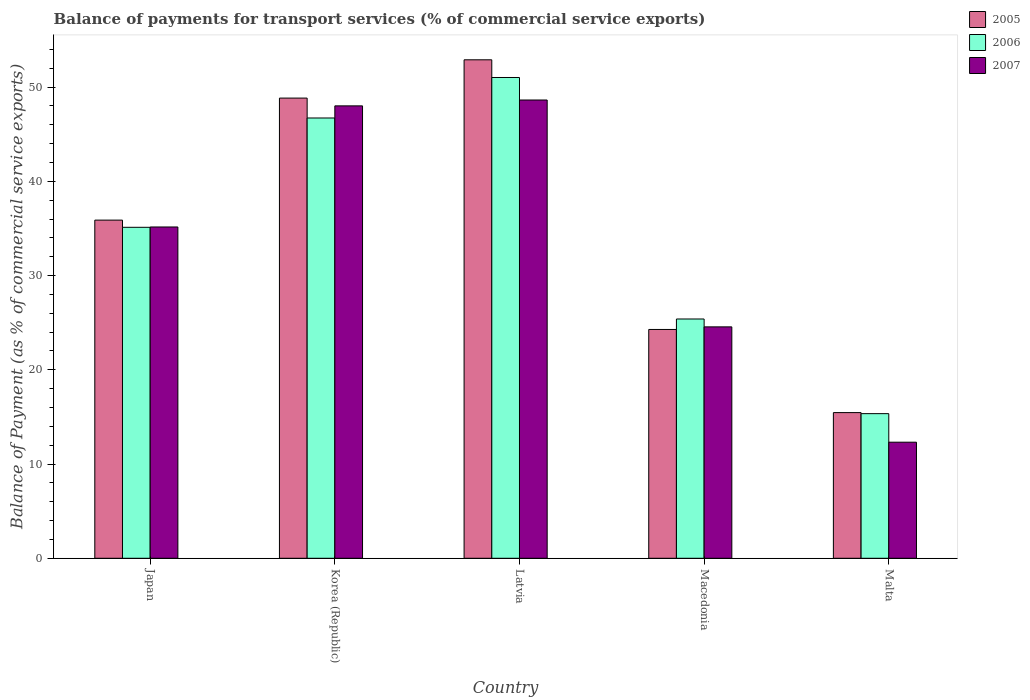Are the number of bars per tick equal to the number of legend labels?
Provide a short and direct response. Yes. Are the number of bars on each tick of the X-axis equal?
Ensure brevity in your answer.  Yes. How many bars are there on the 4th tick from the right?
Ensure brevity in your answer.  3. What is the label of the 1st group of bars from the left?
Provide a succinct answer. Japan. What is the balance of payments for transport services in 2007 in Macedonia?
Make the answer very short. 24.56. Across all countries, what is the maximum balance of payments for transport services in 2007?
Your answer should be compact. 48.63. Across all countries, what is the minimum balance of payments for transport services in 2007?
Your answer should be compact. 12.32. In which country was the balance of payments for transport services in 2005 maximum?
Provide a short and direct response. Latvia. In which country was the balance of payments for transport services in 2007 minimum?
Keep it short and to the point. Malta. What is the total balance of payments for transport services in 2005 in the graph?
Offer a very short reply. 177.36. What is the difference between the balance of payments for transport services in 2005 in Korea (Republic) and that in Macedonia?
Keep it short and to the point. 24.55. What is the difference between the balance of payments for transport services in 2006 in Macedonia and the balance of payments for transport services in 2005 in Malta?
Offer a very short reply. 9.93. What is the average balance of payments for transport services in 2006 per country?
Make the answer very short. 34.72. What is the difference between the balance of payments for transport services of/in 2007 and balance of payments for transport services of/in 2005 in Korea (Republic)?
Offer a very short reply. -0.83. In how many countries, is the balance of payments for transport services in 2005 greater than 14 %?
Make the answer very short. 5. What is the ratio of the balance of payments for transport services in 2007 in Latvia to that in Malta?
Keep it short and to the point. 3.95. Is the balance of payments for transport services in 2006 in Korea (Republic) less than that in Latvia?
Your answer should be compact. Yes. Is the difference between the balance of payments for transport services in 2007 in Macedonia and Malta greater than the difference between the balance of payments for transport services in 2005 in Macedonia and Malta?
Offer a terse response. Yes. What is the difference between the highest and the second highest balance of payments for transport services in 2006?
Ensure brevity in your answer.  -15.9. What is the difference between the highest and the lowest balance of payments for transport services in 2006?
Ensure brevity in your answer.  35.67. In how many countries, is the balance of payments for transport services in 2007 greater than the average balance of payments for transport services in 2007 taken over all countries?
Your answer should be compact. 3. Is the sum of the balance of payments for transport services in 2006 in Latvia and Macedonia greater than the maximum balance of payments for transport services in 2005 across all countries?
Your response must be concise. Yes. What does the 2nd bar from the right in Korea (Republic) represents?
Your response must be concise. 2006. How many countries are there in the graph?
Provide a short and direct response. 5. What is the difference between two consecutive major ticks on the Y-axis?
Provide a succinct answer. 10. Are the values on the major ticks of Y-axis written in scientific E-notation?
Give a very brief answer. No. Does the graph contain any zero values?
Offer a very short reply. No. Does the graph contain grids?
Offer a terse response. No. How many legend labels are there?
Keep it short and to the point. 3. How are the legend labels stacked?
Provide a short and direct response. Vertical. What is the title of the graph?
Your response must be concise. Balance of payments for transport services (% of commercial service exports). What is the label or title of the X-axis?
Provide a short and direct response. Country. What is the label or title of the Y-axis?
Offer a very short reply. Balance of Payment (as % of commercial service exports). What is the Balance of Payment (as % of commercial service exports) of 2005 in Japan?
Offer a very short reply. 35.89. What is the Balance of Payment (as % of commercial service exports) in 2006 in Japan?
Your answer should be very brief. 35.12. What is the Balance of Payment (as % of commercial service exports) in 2007 in Japan?
Make the answer very short. 35.16. What is the Balance of Payment (as % of commercial service exports) of 2005 in Korea (Republic)?
Ensure brevity in your answer.  48.84. What is the Balance of Payment (as % of commercial service exports) in 2006 in Korea (Republic)?
Your answer should be compact. 46.72. What is the Balance of Payment (as % of commercial service exports) of 2007 in Korea (Republic)?
Make the answer very short. 48.01. What is the Balance of Payment (as % of commercial service exports) of 2005 in Latvia?
Give a very brief answer. 52.9. What is the Balance of Payment (as % of commercial service exports) in 2006 in Latvia?
Offer a very short reply. 51.02. What is the Balance of Payment (as % of commercial service exports) in 2007 in Latvia?
Make the answer very short. 48.63. What is the Balance of Payment (as % of commercial service exports) in 2005 in Macedonia?
Provide a short and direct response. 24.28. What is the Balance of Payment (as % of commercial service exports) in 2006 in Macedonia?
Give a very brief answer. 25.39. What is the Balance of Payment (as % of commercial service exports) of 2007 in Macedonia?
Your response must be concise. 24.56. What is the Balance of Payment (as % of commercial service exports) of 2005 in Malta?
Ensure brevity in your answer.  15.46. What is the Balance of Payment (as % of commercial service exports) in 2006 in Malta?
Provide a short and direct response. 15.35. What is the Balance of Payment (as % of commercial service exports) in 2007 in Malta?
Offer a very short reply. 12.32. Across all countries, what is the maximum Balance of Payment (as % of commercial service exports) in 2005?
Make the answer very short. 52.9. Across all countries, what is the maximum Balance of Payment (as % of commercial service exports) of 2006?
Provide a short and direct response. 51.02. Across all countries, what is the maximum Balance of Payment (as % of commercial service exports) in 2007?
Keep it short and to the point. 48.63. Across all countries, what is the minimum Balance of Payment (as % of commercial service exports) in 2005?
Offer a very short reply. 15.46. Across all countries, what is the minimum Balance of Payment (as % of commercial service exports) of 2006?
Give a very brief answer. 15.35. Across all countries, what is the minimum Balance of Payment (as % of commercial service exports) in 2007?
Give a very brief answer. 12.32. What is the total Balance of Payment (as % of commercial service exports) of 2005 in the graph?
Your answer should be compact. 177.36. What is the total Balance of Payment (as % of commercial service exports) of 2006 in the graph?
Your answer should be very brief. 173.61. What is the total Balance of Payment (as % of commercial service exports) of 2007 in the graph?
Keep it short and to the point. 168.67. What is the difference between the Balance of Payment (as % of commercial service exports) of 2005 in Japan and that in Korea (Republic)?
Offer a terse response. -12.95. What is the difference between the Balance of Payment (as % of commercial service exports) in 2006 in Japan and that in Korea (Republic)?
Make the answer very short. -11.6. What is the difference between the Balance of Payment (as % of commercial service exports) of 2007 in Japan and that in Korea (Republic)?
Your answer should be compact. -12.85. What is the difference between the Balance of Payment (as % of commercial service exports) in 2005 in Japan and that in Latvia?
Offer a terse response. -17.01. What is the difference between the Balance of Payment (as % of commercial service exports) in 2006 in Japan and that in Latvia?
Provide a short and direct response. -15.9. What is the difference between the Balance of Payment (as % of commercial service exports) of 2007 in Japan and that in Latvia?
Your answer should be very brief. -13.47. What is the difference between the Balance of Payment (as % of commercial service exports) of 2005 in Japan and that in Macedonia?
Give a very brief answer. 11.6. What is the difference between the Balance of Payment (as % of commercial service exports) of 2006 in Japan and that in Macedonia?
Provide a succinct answer. 9.73. What is the difference between the Balance of Payment (as % of commercial service exports) of 2007 in Japan and that in Macedonia?
Provide a succinct answer. 10.6. What is the difference between the Balance of Payment (as % of commercial service exports) in 2005 in Japan and that in Malta?
Keep it short and to the point. 20.43. What is the difference between the Balance of Payment (as % of commercial service exports) of 2006 in Japan and that in Malta?
Provide a succinct answer. 19.78. What is the difference between the Balance of Payment (as % of commercial service exports) in 2007 in Japan and that in Malta?
Give a very brief answer. 22.84. What is the difference between the Balance of Payment (as % of commercial service exports) of 2005 in Korea (Republic) and that in Latvia?
Give a very brief answer. -4.06. What is the difference between the Balance of Payment (as % of commercial service exports) of 2006 in Korea (Republic) and that in Latvia?
Your response must be concise. -4.3. What is the difference between the Balance of Payment (as % of commercial service exports) of 2007 in Korea (Republic) and that in Latvia?
Give a very brief answer. -0.62. What is the difference between the Balance of Payment (as % of commercial service exports) of 2005 in Korea (Republic) and that in Macedonia?
Give a very brief answer. 24.55. What is the difference between the Balance of Payment (as % of commercial service exports) of 2006 in Korea (Republic) and that in Macedonia?
Your answer should be compact. 21.33. What is the difference between the Balance of Payment (as % of commercial service exports) of 2007 in Korea (Republic) and that in Macedonia?
Your answer should be compact. 23.45. What is the difference between the Balance of Payment (as % of commercial service exports) in 2005 in Korea (Republic) and that in Malta?
Your response must be concise. 33.38. What is the difference between the Balance of Payment (as % of commercial service exports) in 2006 in Korea (Republic) and that in Malta?
Provide a short and direct response. 31.38. What is the difference between the Balance of Payment (as % of commercial service exports) of 2007 in Korea (Republic) and that in Malta?
Provide a succinct answer. 35.69. What is the difference between the Balance of Payment (as % of commercial service exports) of 2005 in Latvia and that in Macedonia?
Your response must be concise. 28.62. What is the difference between the Balance of Payment (as % of commercial service exports) of 2006 in Latvia and that in Macedonia?
Make the answer very short. 25.63. What is the difference between the Balance of Payment (as % of commercial service exports) in 2007 in Latvia and that in Macedonia?
Provide a short and direct response. 24.07. What is the difference between the Balance of Payment (as % of commercial service exports) in 2005 in Latvia and that in Malta?
Keep it short and to the point. 37.44. What is the difference between the Balance of Payment (as % of commercial service exports) of 2006 in Latvia and that in Malta?
Ensure brevity in your answer.  35.67. What is the difference between the Balance of Payment (as % of commercial service exports) in 2007 in Latvia and that in Malta?
Ensure brevity in your answer.  36.31. What is the difference between the Balance of Payment (as % of commercial service exports) of 2005 in Macedonia and that in Malta?
Provide a succinct answer. 8.82. What is the difference between the Balance of Payment (as % of commercial service exports) in 2006 in Macedonia and that in Malta?
Offer a very short reply. 10.04. What is the difference between the Balance of Payment (as % of commercial service exports) of 2007 in Macedonia and that in Malta?
Your response must be concise. 12.24. What is the difference between the Balance of Payment (as % of commercial service exports) in 2005 in Japan and the Balance of Payment (as % of commercial service exports) in 2006 in Korea (Republic)?
Provide a succinct answer. -10.84. What is the difference between the Balance of Payment (as % of commercial service exports) in 2005 in Japan and the Balance of Payment (as % of commercial service exports) in 2007 in Korea (Republic)?
Your answer should be very brief. -12.12. What is the difference between the Balance of Payment (as % of commercial service exports) of 2006 in Japan and the Balance of Payment (as % of commercial service exports) of 2007 in Korea (Republic)?
Offer a terse response. -12.89. What is the difference between the Balance of Payment (as % of commercial service exports) in 2005 in Japan and the Balance of Payment (as % of commercial service exports) in 2006 in Latvia?
Give a very brief answer. -15.14. What is the difference between the Balance of Payment (as % of commercial service exports) of 2005 in Japan and the Balance of Payment (as % of commercial service exports) of 2007 in Latvia?
Make the answer very short. -12.75. What is the difference between the Balance of Payment (as % of commercial service exports) in 2006 in Japan and the Balance of Payment (as % of commercial service exports) in 2007 in Latvia?
Your response must be concise. -13.51. What is the difference between the Balance of Payment (as % of commercial service exports) of 2005 in Japan and the Balance of Payment (as % of commercial service exports) of 2006 in Macedonia?
Your response must be concise. 10.49. What is the difference between the Balance of Payment (as % of commercial service exports) of 2005 in Japan and the Balance of Payment (as % of commercial service exports) of 2007 in Macedonia?
Make the answer very short. 11.33. What is the difference between the Balance of Payment (as % of commercial service exports) of 2006 in Japan and the Balance of Payment (as % of commercial service exports) of 2007 in Macedonia?
Keep it short and to the point. 10.57. What is the difference between the Balance of Payment (as % of commercial service exports) in 2005 in Japan and the Balance of Payment (as % of commercial service exports) in 2006 in Malta?
Make the answer very short. 20.54. What is the difference between the Balance of Payment (as % of commercial service exports) in 2005 in Japan and the Balance of Payment (as % of commercial service exports) in 2007 in Malta?
Keep it short and to the point. 23.57. What is the difference between the Balance of Payment (as % of commercial service exports) in 2006 in Japan and the Balance of Payment (as % of commercial service exports) in 2007 in Malta?
Offer a very short reply. 22.81. What is the difference between the Balance of Payment (as % of commercial service exports) in 2005 in Korea (Republic) and the Balance of Payment (as % of commercial service exports) in 2006 in Latvia?
Provide a short and direct response. -2.19. What is the difference between the Balance of Payment (as % of commercial service exports) in 2005 in Korea (Republic) and the Balance of Payment (as % of commercial service exports) in 2007 in Latvia?
Your response must be concise. 0.2. What is the difference between the Balance of Payment (as % of commercial service exports) in 2006 in Korea (Republic) and the Balance of Payment (as % of commercial service exports) in 2007 in Latvia?
Keep it short and to the point. -1.91. What is the difference between the Balance of Payment (as % of commercial service exports) of 2005 in Korea (Republic) and the Balance of Payment (as % of commercial service exports) of 2006 in Macedonia?
Provide a succinct answer. 23.44. What is the difference between the Balance of Payment (as % of commercial service exports) in 2005 in Korea (Republic) and the Balance of Payment (as % of commercial service exports) in 2007 in Macedonia?
Your response must be concise. 24.28. What is the difference between the Balance of Payment (as % of commercial service exports) of 2006 in Korea (Republic) and the Balance of Payment (as % of commercial service exports) of 2007 in Macedonia?
Your answer should be compact. 22.17. What is the difference between the Balance of Payment (as % of commercial service exports) of 2005 in Korea (Republic) and the Balance of Payment (as % of commercial service exports) of 2006 in Malta?
Your answer should be compact. 33.49. What is the difference between the Balance of Payment (as % of commercial service exports) of 2005 in Korea (Republic) and the Balance of Payment (as % of commercial service exports) of 2007 in Malta?
Your response must be concise. 36.52. What is the difference between the Balance of Payment (as % of commercial service exports) in 2006 in Korea (Republic) and the Balance of Payment (as % of commercial service exports) in 2007 in Malta?
Offer a very short reply. 34.41. What is the difference between the Balance of Payment (as % of commercial service exports) in 2005 in Latvia and the Balance of Payment (as % of commercial service exports) in 2006 in Macedonia?
Your answer should be compact. 27.51. What is the difference between the Balance of Payment (as % of commercial service exports) of 2005 in Latvia and the Balance of Payment (as % of commercial service exports) of 2007 in Macedonia?
Offer a very short reply. 28.34. What is the difference between the Balance of Payment (as % of commercial service exports) in 2006 in Latvia and the Balance of Payment (as % of commercial service exports) in 2007 in Macedonia?
Your response must be concise. 26.47. What is the difference between the Balance of Payment (as % of commercial service exports) of 2005 in Latvia and the Balance of Payment (as % of commercial service exports) of 2006 in Malta?
Your answer should be compact. 37.55. What is the difference between the Balance of Payment (as % of commercial service exports) of 2005 in Latvia and the Balance of Payment (as % of commercial service exports) of 2007 in Malta?
Ensure brevity in your answer.  40.58. What is the difference between the Balance of Payment (as % of commercial service exports) in 2006 in Latvia and the Balance of Payment (as % of commercial service exports) in 2007 in Malta?
Offer a terse response. 38.7. What is the difference between the Balance of Payment (as % of commercial service exports) in 2005 in Macedonia and the Balance of Payment (as % of commercial service exports) in 2006 in Malta?
Make the answer very short. 8.93. What is the difference between the Balance of Payment (as % of commercial service exports) of 2005 in Macedonia and the Balance of Payment (as % of commercial service exports) of 2007 in Malta?
Provide a short and direct response. 11.96. What is the difference between the Balance of Payment (as % of commercial service exports) in 2006 in Macedonia and the Balance of Payment (as % of commercial service exports) in 2007 in Malta?
Your answer should be compact. 13.07. What is the average Balance of Payment (as % of commercial service exports) in 2005 per country?
Provide a succinct answer. 35.47. What is the average Balance of Payment (as % of commercial service exports) in 2006 per country?
Keep it short and to the point. 34.72. What is the average Balance of Payment (as % of commercial service exports) of 2007 per country?
Make the answer very short. 33.73. What is the difference between the Balance of Payment (as % of commercial service exports) of 2005 and Balance of Payment (as % of commercial service exports) of 2006 in Japan?
Make the answer very short. 0.76. What is the difference between the Balance of Payment (as % of commercial service exports) in 2005 and Balance of Payment (as % of commercial service exports) in 2007 in Japan?
Provide a succinct answer. 0.73. What is the difference between the Balance of Payment (as % of commercial service exports) in 2006 and Balance of Payment (as % of commercial service exports) in 2007 in Japan?
Your answer should be compact. -0.03. What is the difference between the Balance of Payment (as % of commercial service exports) in 2005 and Balance of Payment (as % of commercial service exports) in 2006 in Korea (Republic)?
Ensure brevity in your answer.  2.11. What is the difference between the Balance of Payment (as % of commercial service exports) of 2005 and Balance of Payment (as % of commercial service exports) of 2007 in Korea (Republic)?
Give a very brief answer. 0.83. What is the difference between the Balance of Payment (as % of commercial service exports) in 2006 and Balance of Payment (as % of commercial service exports) in 2007 in Korea (Republic)?
Give a very brief answer. -1.29. What is the difference between the Balance of Payment (as % of commercial service exports) in 2005 and Balance of Payment (as % of commercial service exports) in 2006 in Latvia?
Your answer should be very brief. 1.88. What is the difference between the Balance of Payment (as % of commercial service exports) of 2005 and Balance of Payment (as % of commercial service exports) of 2007 in Latvia?
Your response must be concise. 4.27. What is the difference between the Balance of Payment (as % of commercial service exports) of 2006 and Balance of Payment (as % of commercial service exports) of 2007 in Latvia?
Your response must be concise. 2.39. What is the difference between the Balance of Payment (as % of commercial service exports) of 2005 and Balance of Payment (as % of commercial service exports) of 2006 in Macedonia?
Provide a short and direct response. -1.11. What is the difference between the Balance of Payment (as % of commercial service exports) in 2005 and Balance of Payment (as % of commercial service exports) in 2007 in Macedonia?
Offer a very short reply. -0.28. What is the difference between the Balance of Payment (as % of commercial service exports) in 2006 and Balance of Payment (as % of commercial service exports) in 2007 in Macedonia?
Give a very brief answer. 0.84. What is the difference between the Balance of Payment (as % of commercial service exports) of 2005 and Balance of Payment (as % of commercial service exports) of 2006 in Malta?
Ensure brevity in your answer.  0.11. What is the difference between the Balance of Payment (as % of commercial service exports) in 2005 and Balance of Payment (as % of commercial service exports) in 2007 in Malta?
Provide a short and direct response. 3.14. What is the difference between the Balance of Payment (as % of commercial service exports) of 2006 and Balance of Payment (as % of commercial service exports) of 2007 in Malta?
Your response must be concise. 3.03. What is the ratio of the Balance of Payment (as % of commercial service exports) of 2005 in Japan to that in Korea (Republic)?
Offer a terse response. 0.73. What is the ratio of the Balance of Payment (as % of commercial service exports) of 2006 in Japan to that in Korea (Republic)?
Give a very brief answer. 0.75. What is the ratio of the Balance of Payment (as % of commercial service exports) in 2007 in Japan to that in Korea (Republic)?
Give a very brief answer. 0.73. What is the ratio of the Balance of Payment (as % of commercial service exports) in 2005 in Japan to that in Latvia?
Provide a short and direct response. 0.68. What is the ratio of the Balance of Payment (as % of commercial service exports) in 2006 in Japan to that in Latvia?
Keep it short and to the point. 0.69. What is the ratio of the Balance of Payment (as % of commercial service exports) in 2007 in Japan to that in Latvia?
Keep it short and to the point. 0.72. What is the ratio of the Balance of Payment (as % of commercial service exports) of 2005 in Japan to that in Macedonia?
Keep it short and to the point. 1.48. What is the ratio of the Balance of Payment (as % of commercial service exports) in 2006 in Japan to that in Macedonia?
Offer a very short reply. 1.38. What is the ratio of the Balance of Payment (as % of commercial service exports) of 2007 in Japan to that in Macedonia?
Provide a succinct answer. 1.43. What is the ratio of the Balance of Payment (as % of commercial service exports) of 2005 in Japan to that in Malta?
Give a very brief answer. 2.32. What is the ratio of the Balance of Payment (as % of commercial service exports) of 2006 in Japan to that in Malta?
Ensure brevity in your answer.  2.29. What is the ratio of the Balance of Payment (as % of commercial service exports) in 2007 in Japan to that in Malta?
Offer a very short reply. 2.85. What is the ratio of the Balance of Payment (as % of commercial service exports) in 2005 in Korea (Republic) to that in Latvia?
Provide a short and direct response. 0.92. What is the ratio of the Balance of Payment (as % of commercial service exports) of 2006 in Korea (Republic) to that in Latvia?
Make the answer very short. 0.92. What is the ratio of the Balance of Payment (as % of commercial service exports) of 2007 in Korea (Republic) to that in Latvia?
Make the answer very short. 0.99. What is the ratio of the Balance of Payment (as % of commercial service exports) of 2005 in Korea (Republic) to that in Macedonia?
Give a very brief answer. 2.01. What is the ratio of the Balance of Payment (as % of commercial service exports) of 2006 in Korea (Republic) to that in Macedonia?
Provide a short and direct response. 1.84. What is the ratio of the Balance of Payment (as % of commercial service exports) of 2007 in Korea (Republic) to that in Macedonia?
Your answer should be very brief. 1.96. What is the ratio of the Balance of Payment (as % of commercial service exports) of 2005 in Korea (Republic) to that in Malta?
Offer a terse response. 3.16. What is the ratio of the Balance of Payment (as % of commercial service exports) in 2006 in Korea (Republic) to that in Malta?
Your answer should be very brief. 3.04. What is the ratio of the Balance of Payment (as % of commercial service exports) of 2007 in Korea (Republic) to that in Malta?
Your answer should be compact. 3.9. What is the ratio of the Balance of Payment (as % of commercial service exports) in 2005 in Latvia to that in Macedonia?
Your answer should be very brief. 2.18. What is the ratio of the Balance of Payment (as % of commercial service exports) of 2006 in Latvia to that in Macedonia?
Keep it short and to the point. 2.01. What is the ratio of the Balance of Payment (as % of commercial service exports) of 2007 in Latvia to that in Macedonia?
Keep it short and to the point. 1.98. What is the ratio of the Balance of Payment (as % of commercial service exports) in 2005 in Latvia to that in Malta?
Your answer should be very brief. 3.42. What is the ratio of the Balance of Payment (as % of commercial service exports) in 2006 in Latvia to that in Malta?
Provide a short and direct response. 3.32. What is the ratio of the Balance of Payment (as % of commercial service exports) of 2007 in Latvia to that in Malta?
Your response must be concise. 3.95. What is the ratio of the Balance of Payment (as % of commercial service exports) of 2005 in Macedonia to that in Malta?
Provide a short and direct response. 1.57. What is the ratio of the Balance of Payment (as % of commercial service exports) in 2006 in Macedonia to that in Malta?
Offer a very short reply. 1.65. What is the ratio of the Balance of Payment (as % of commercial service exports) of 2007 in Macedonia to that in Malta?
Provide a succinct answer. 1.99. What is the difference between the highest and the second highest Balance of Payment (as % of commercial service exports) of 2005?
Offer a very short reply. 4.06. What is the difference between the highest and the second highest Balance of Payment (as % of commercial service exports) of 2006?
Your answer should be compact. 4.3. What is the difference between the highest and the second highest Balance of Payment (as % of commercial service exports) of 2007?
Make the answer very short. 0.62. What is the difference between the highest and the lowest Balance of Payment (as % of commercial service exports) in 2005?
Your answer should be very brief. 37.44. What is the difference between the highest and the lowest Balance of Payment (as % of commercial service exports) in 2006?
Give a very brief answer. 35.67. What is the difference between the highest and the lowest Balance of Payment (as % of commercial service exports) of 2007?
Keep it short and to the point. 36.31. 